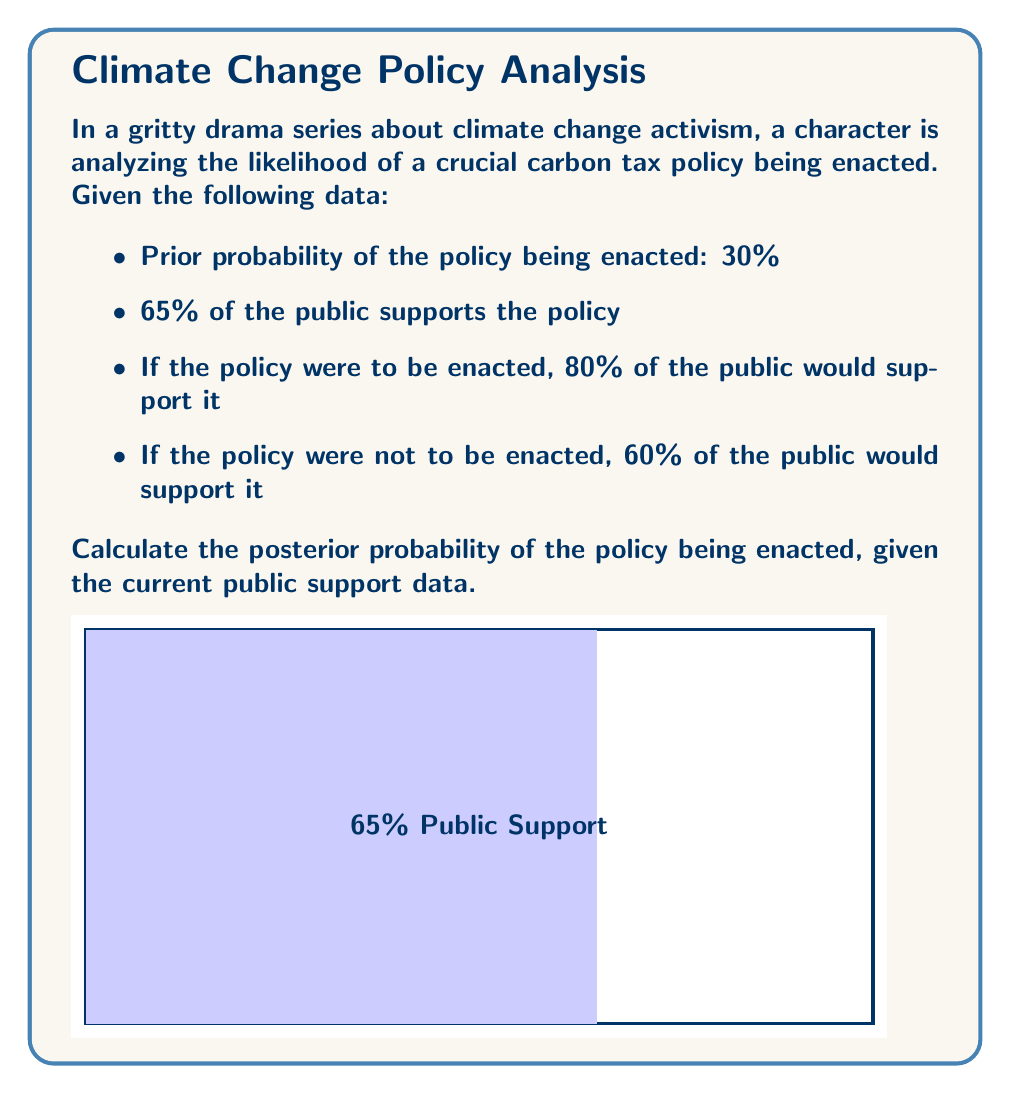Provide a solution to this math problem. To solve this problem, we'll use Bayes' theorem. Let's define our events:

E: The policy is enacted
S: The public supports the policy

We're given:
P(E) = 0.30 (prior probability)
P(S|E) = 0.80 (likelihood of support given enactment)
P(S|not E) = 0.60 (likelihood of support given no enactment)
P(S) = 0.65 (current public support)

Bayes' theorem states:

$$ P(E|S) = \frac{P(S|E) \cdot P(E)}{P(S)} $$

We need to calculate P(S) using the law of total probability:

$$ P(S) = P(S|E) \cdot P(E) + P(S|not E) \cdot P(not E) $$

Step 1: Calculate P(not E)
$P(not E) = 1 - P(E) = 1 - 0.30 = 0.70$

Step 2: Verify P(S)
$P(S) = 0.80 \cdot 0.30 + 0.60 \cdot 0.70 = 0.24 + 0.42 = 0.66$

This is close to the given 0.65, so we'll use 0.65 for consistency.

Step 3: Apply Bayes' theorem
$$ P(E|S) = \frac{0.80 \cdot 0.30}{0.65} = \frac{0.24}{0.65} \approx 0.3692 $$

Therefore, the posterior probability of the policy being enacted, given the current public support, is approximately 36.92%.
Answer: $0.3692$ or $36.92\%$ 